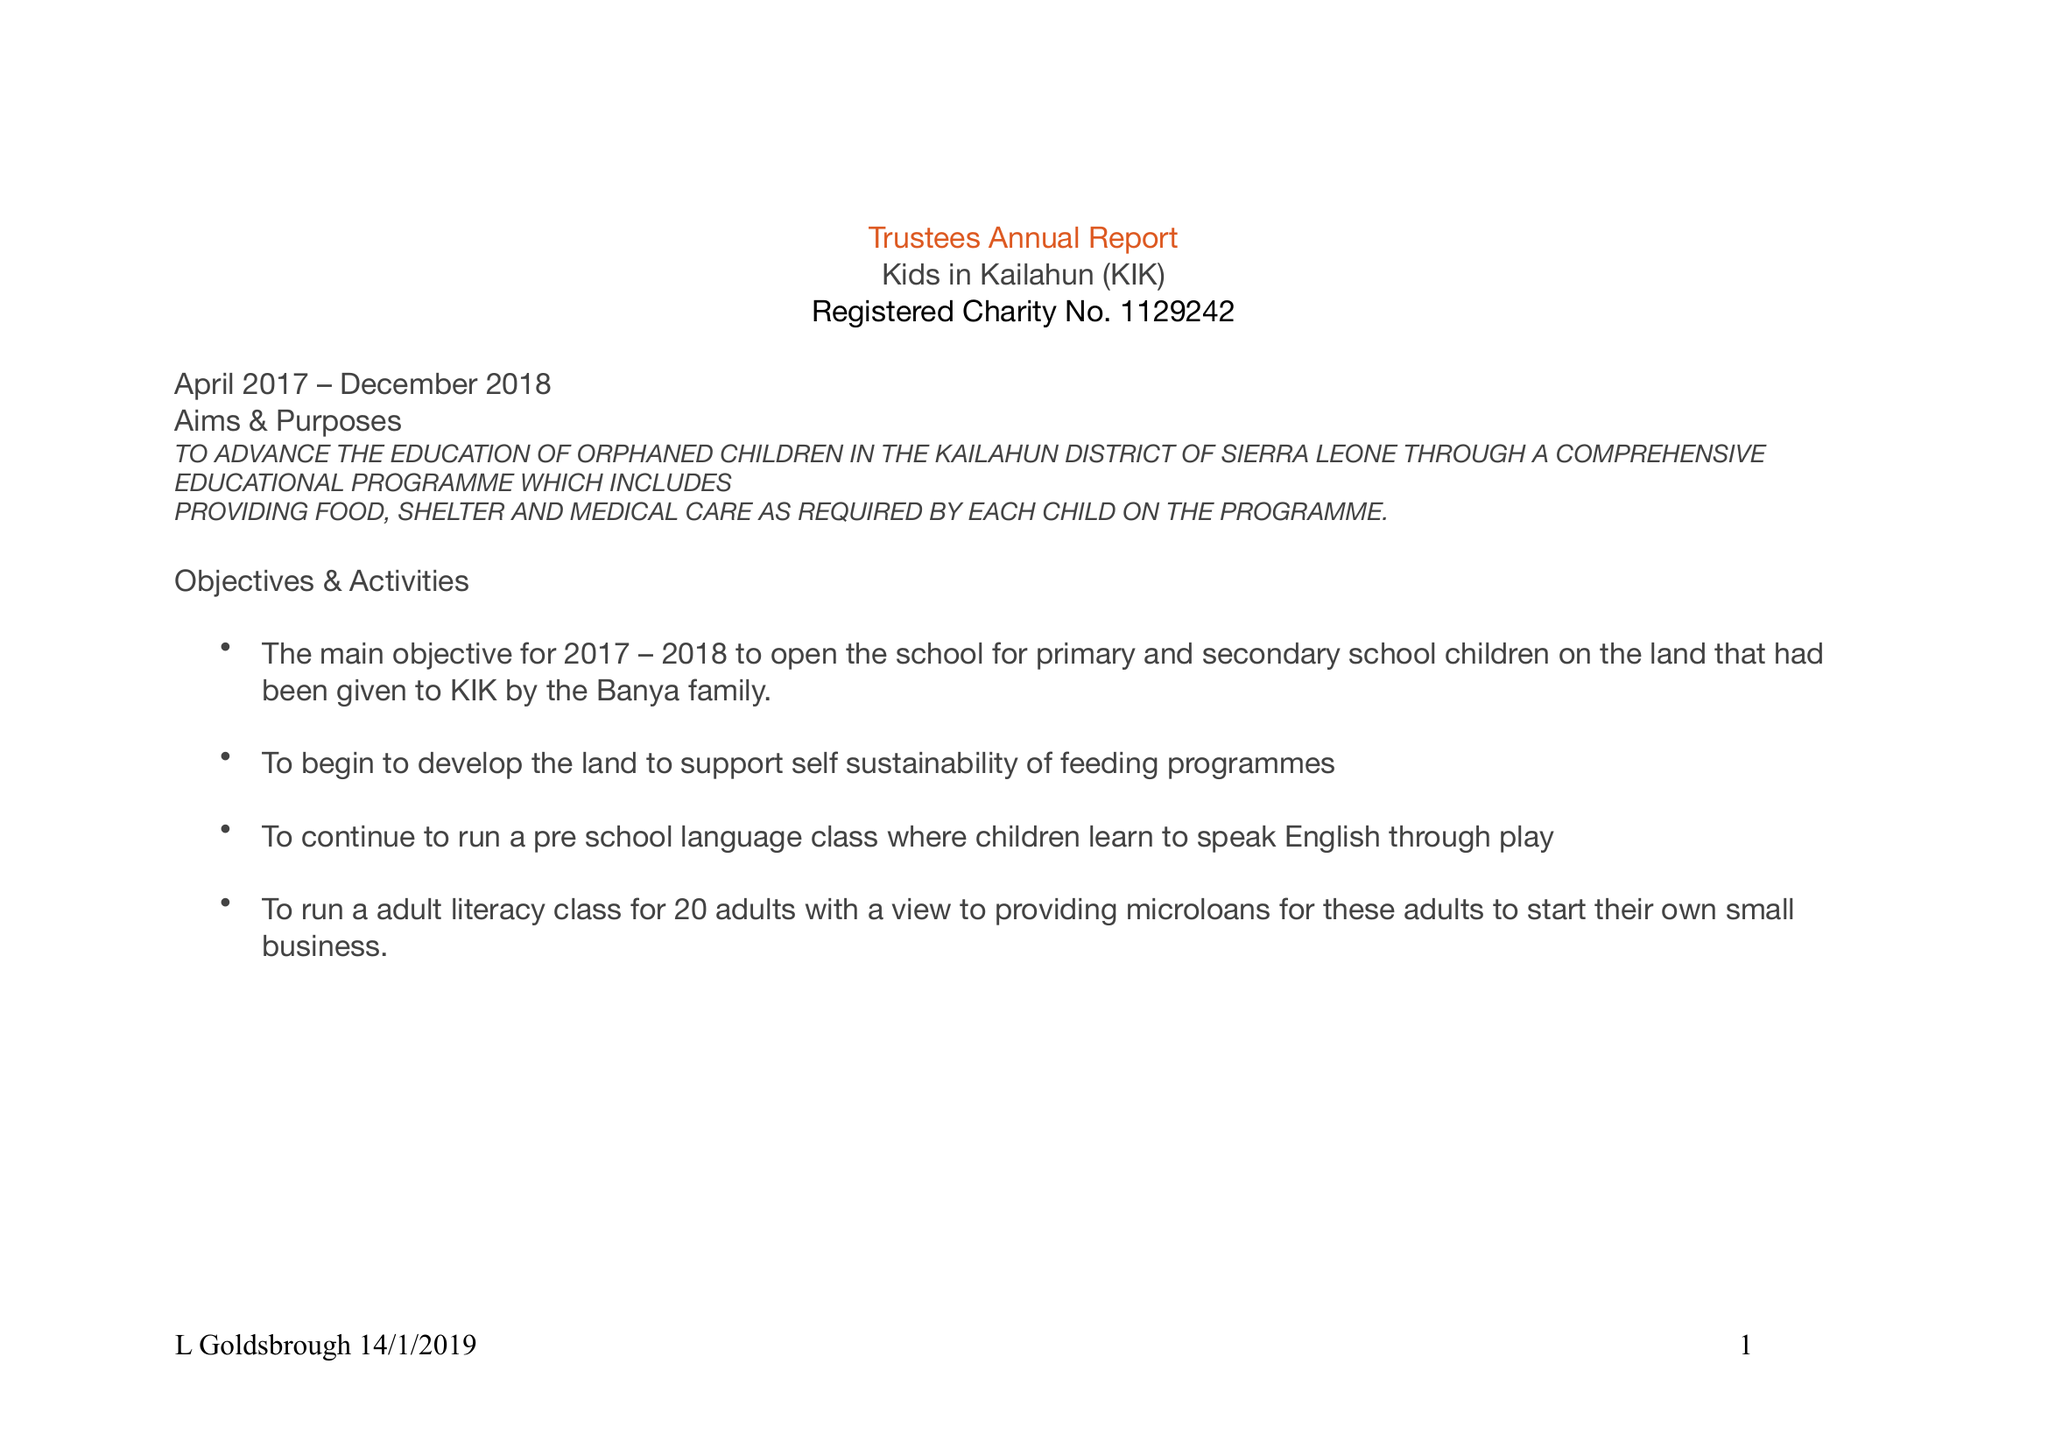What is the value for the charity_number?
Answer the question using a single word or phrase. 1129242 